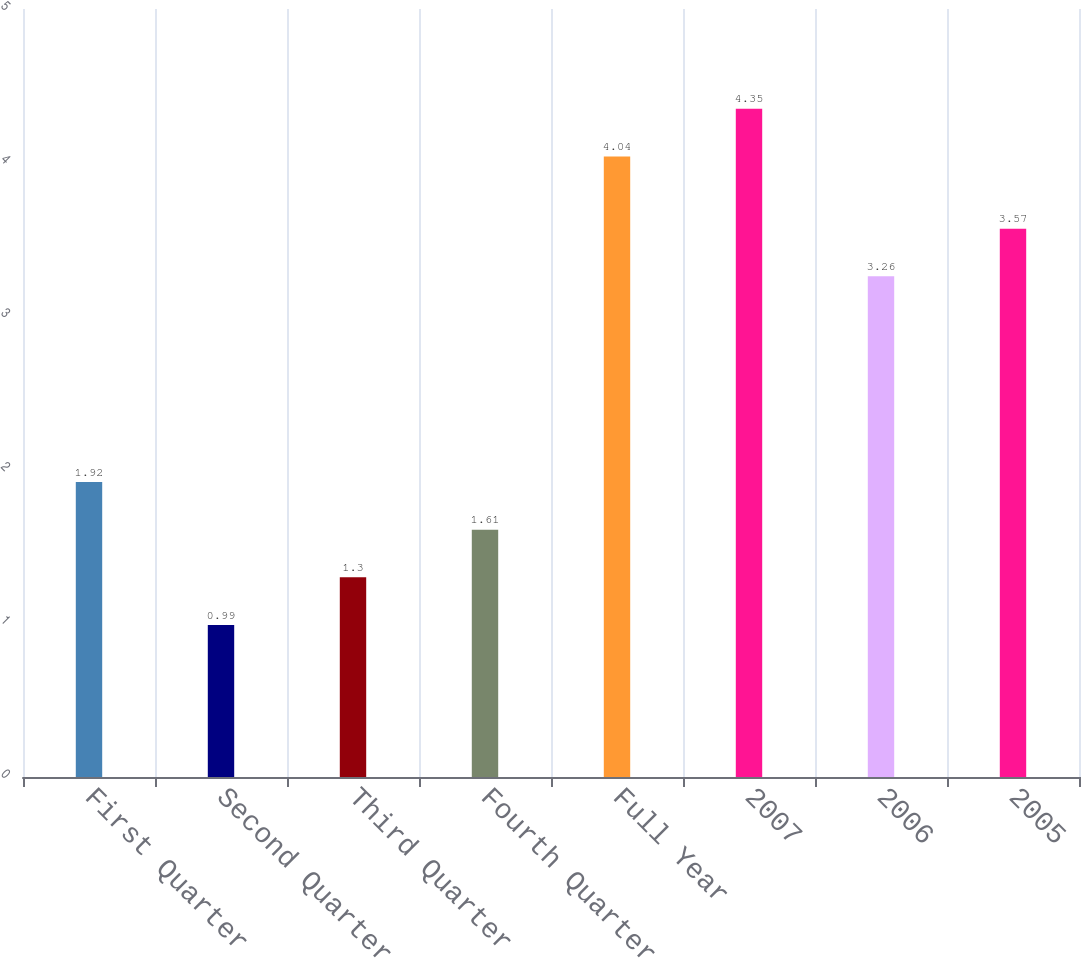<chart> <loc_0><loc_0><loc_500><loc_500><bar_chart><fcel>First Quarter<fcel>Second Quarter<fcel>Third Quarter<fcel>Fourth Quarter<fcel>Full Year<fcel>2007<fcel>2006<fcel>2005<nl><fcel>1.92<fcel>0.99<fcel>1.3<fcel>1.61<fcel>4.04<fcel>4.35<fcel>3.26<fcel>3.57<nl></chart> 